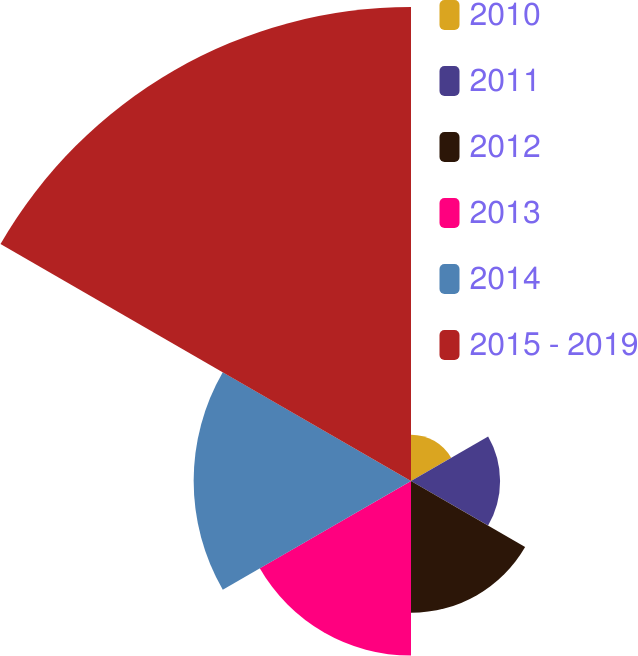<chart> <loc_0><loc_0><loc_500><loc_500><pie_chart><fcel>2010<fcel>2011<fcel>2012<fcel>2013<fcel>2014<fcel>2015 - 2019<nl><fcel>4.09%<fcel>7.86%<fcel>11.63%<fcel>15.41%<fcel>19.18%<fcel>41.83%<nl></chart> 